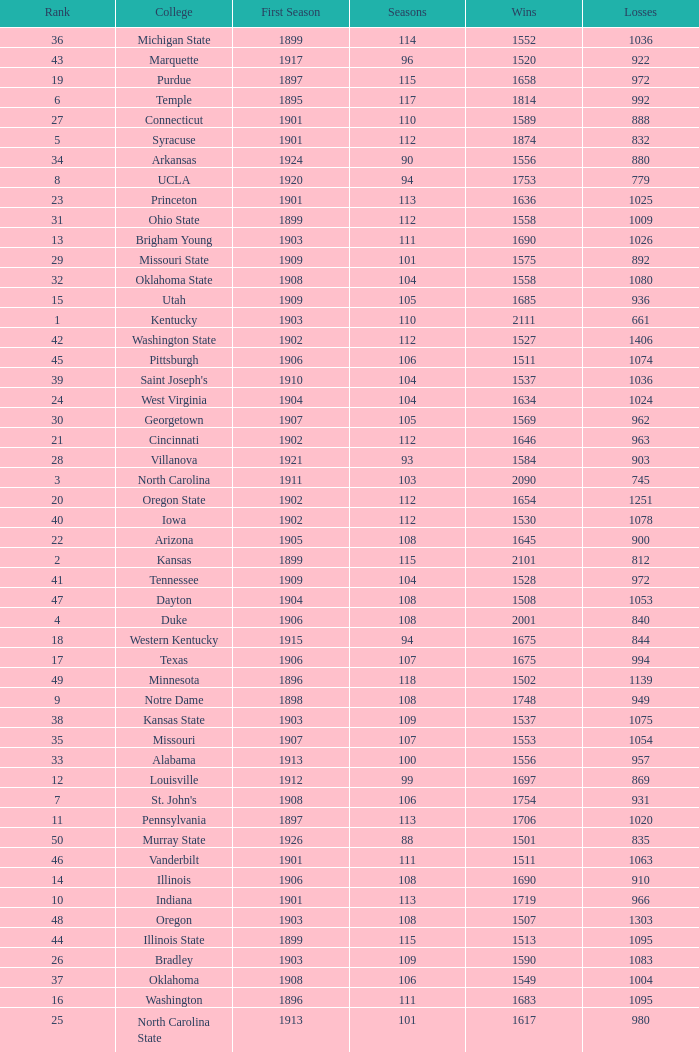How many wins were there for Washington State College with losses greater than 980 and a first season before 1906 and rank greater than 42? 0.0. Would you mind parsing the complete table? {'header': ['Rank', 'College', 'First Season', 'Seasons', 'Wins', 'Losses'], 'rows': [['36', 'Michigan State', '1899', '114', '1552', '1036'], ['43', 'Marquette', '1917', '96', '1520', '922'], ['19', 'Purdue', '1897', '115', '1658', '972'], ['6', 'Temple', '1895', '117', '1814', '992'], ['27', 'Connecticut', '1901', '110', '1589', '888'], ['5', 'Syracuse', '1901', '112', '1874', '832'], ['34', 'Arkansas', '1924', '90', '1556', '880'], ['8', 'UCLA', '1920', '94', '1753', '779'], ['23', 'Princeton', '1901', '113', '1636', '1025'], ['31', 'Ohio State', '1899', '112', '1558', '1009'], ['13', 'Brigham Young', '1903', '111', '1690', '1026'], ['29', 'Missouri State', '1909', '101', '1575', '892'], ['32', 'Oklahoma State', '1908', '104', '1558', '1080'], ['15', 'Utah', '1909', '105', '1685', '936'], ['1', 'Kentucky', '1903', '110', '2111', '661'], ['42', 'Washington State', '1902', '112', '1527', '1406'], ['45', 'Pittsburgh', '1906', '106', '1511', '1074'], ['39', "Saint Joseph's", '1910', '104', '1537', '1036'], ['24', 'West Virginia', '1904', '104', '1634', '1024'], ['30', 'Georgetown', '1907', '105', '1569', '962'], ['21', 'Cincinnati', '1902', '112', '1646', '963'], ['28', 'Villanova', '1921', '93', '1584', '903'], ['3', 'North Carolina', '1911', '103', '2090', '745'], ['20', 'Oregon State', '1902', '112', '1654', '1251'], ['40', 'Iowa', '1902', '112', '1530', '1078'], ['22', 'Arizona', '1905', '108', '1645', '900'], ['2', 'Kansas', '1899', '115', '2101', '812'], ['41', 'Tennessee', '1909', '104', '1528', '972'], ['47', 'Dayton', '1904', '108', '1508', '1053'], ['4', 'Duke', '1906', '108', '2001', '840'], ['18', 'Western Kentucky', '1915', '94', '1675', '844'], ['17', 'Texas', '1906', '107', '1675', '994'], ['49', 'Minnesota', '1896', '118', '1502', '1139'], ['9', 'Notre Dame', '1898', '108', '1748', '949'], ['38', 'Kansas State', '1903', '109', '1537', '1075'], ['35', 'Missouri', '1907', '107', '1553', '1054'], ['33', 'Alabama', '1913', '100', '1556', '957'], ['12', 'Louisville', '1912', '99', '1697', '869'], ['7', "St. John's", '1908', '106', '1754', '931'], ['11', 'Pennsylvania', '1897', '113', '1706', '1020'], ['50', 'Murray State', '1926', '88', '1501', '835'], ['46', 'Vanderbilt', '1901', '111', '1511', '1063'], ['14', 'Illinois', '1906', '108', '1690', '910'], ['10', 'Indiana', '1901', '113', '1719', '966'], ['48', 'Oregon', '1903', '108', '1507', '1303'], ['44', 'Illinois State', '1899', '115', '1513', '1095'], ['26', 'Bradley', '1903', '109', '1590', '1083'], ['37', 'Oklahoma', '1908', '106', '1549', '1004'], ['16', 'Washington', '1896', '111', '1683', '1095'], ['25', 'North Carolina State', '1913', '101', '1617', '980']]} 